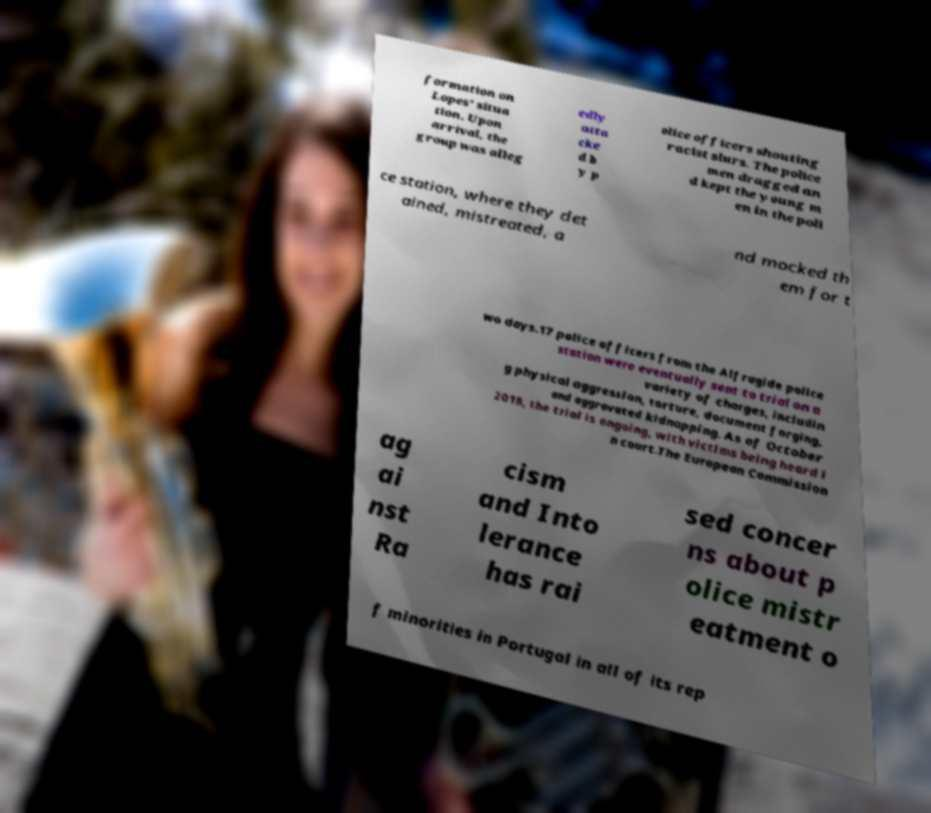Please read and relay the text visible in this image. What does it say? formation on Lopes' situa tion. Upon arrival, the group was alleg edly atta cke d b y p olice officers shouting racist slurs. The police men dragged an d kept the young m en in the poli ce station, where they det ained, mistreated, a nd mocked th em for t wo days.17 police officers from the Alfragide police station were eventually sent to trial on a variety of charges, includin g physical aggression, torture, document forging, and aggravated kidnapping. As of October 2018, the trial is ongoing, with victims being heard i n court.The European Commission ag ai nst Ra cism and Into lerance has rai sed concer ns about p olice mistr eatment o f minorities in Portugal in all of its rep 